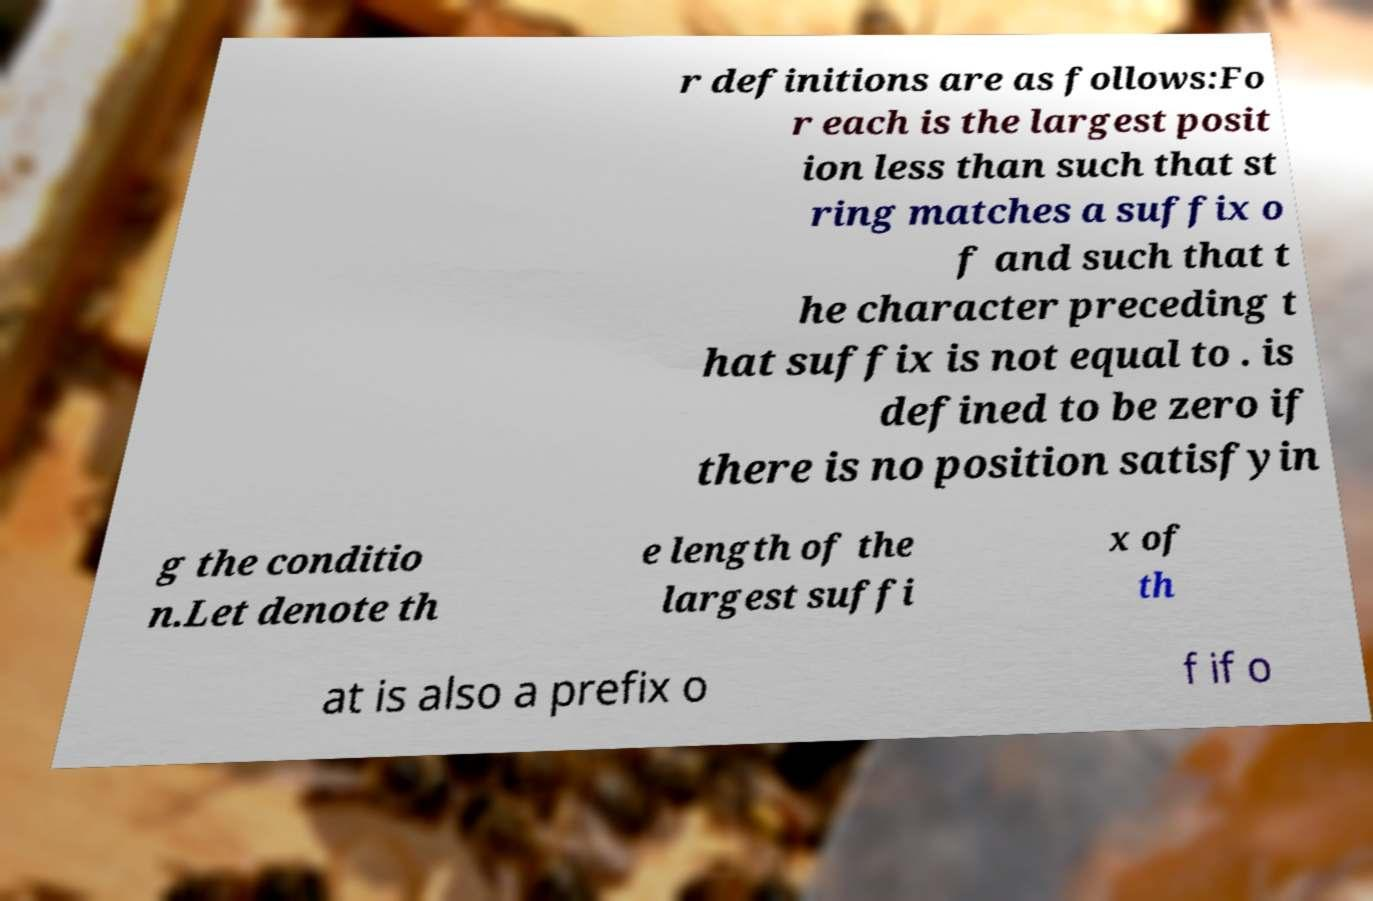What messages or text are displayed in this image? I need them in a readable, typed format. r definitions are as follows:Fo r each is the largest posit ion less than such that st ring matches a suffix o f and such that t he character preceding t hat suffix is not equal to . is defined to be zero if there is no position satisfyin g the conditio n.Let denote th e length of the largest suffi x of th at is also a prefix o f if o 